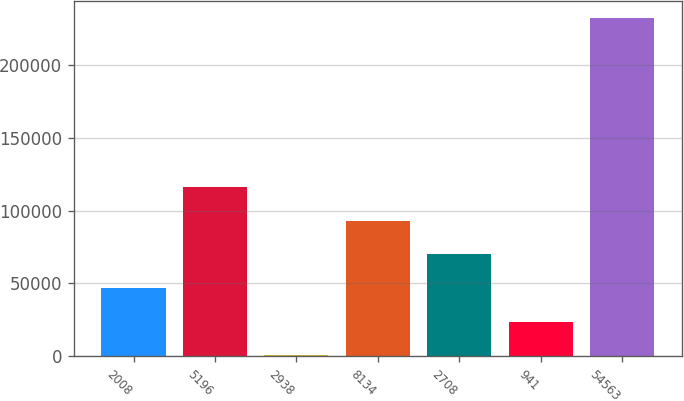Convert chart. <chart><loc_0><loc_0><loc_500><loc_500><bar_chart><fcel>2008<fcel>5196<fcel>2938<fcel>8134<fcel>2708<fcel>941<fcel>54563<nl><fcel>46873.2<fcel>116228<fcel>637<fcel>93109.4<fcel>69991.3<fcel>23755.1<fcel>231818<nl></chart> 